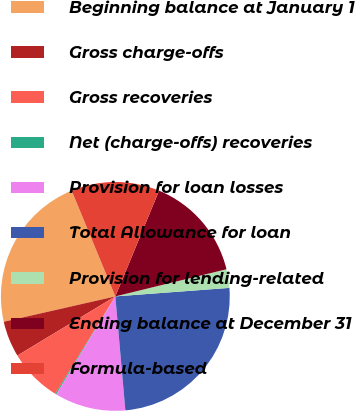<chart> <loc_0><loc_0><loc_500><loc_500><pie_chart><fcel>Beginning balance at January 1<fcel>Gross charge-offs<fcel>Gross recoveries<fcel>Net (charge-offs) recoveries<fcel>Provision for loan losses<fcel>Total Allowance for loan<fcel>Provision for lending-related<fcel>Ending balance at December 31<fcel>Formula-based<nl><fcel>22.33%<fcel>5.09%<fcel>7.56%<fcel>0.17%<fcel>10.02%<fcel>24.79%<fcel>2.63%<fcel>14.94%<fcel>12.48%<nl></chart> 